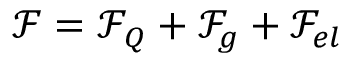Convert formula to latex. <formula><loc_0><loc_0><loc_500><loc_500>\mathcal { F } = \mathcal { F } _ { Q } + \mathcal { F } _ { g } + \mathcal { F } _ { e l }</formula> 